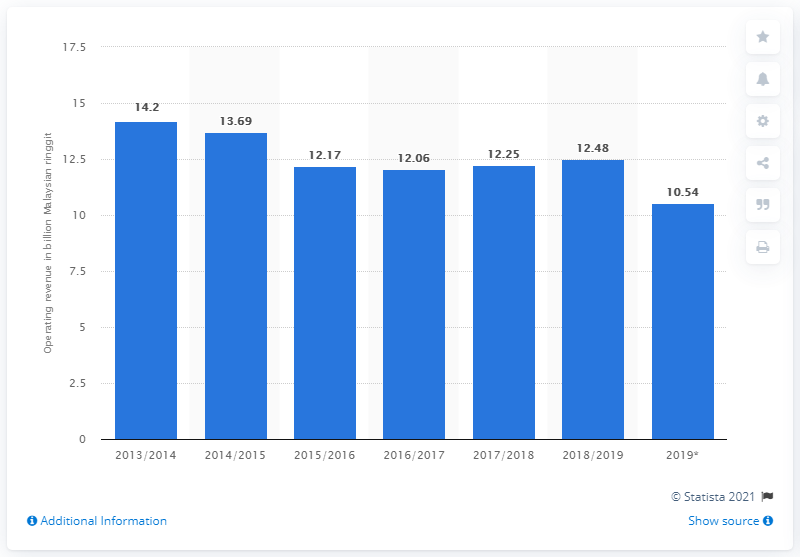Point out several critical features in this image. DRB-HICOM's operating revenue in Malaysian ringgit was 10.54. The average of all the bars is 12.48. The y-axis in the graph represents operating revenue in billion Malaysian ringgit. 